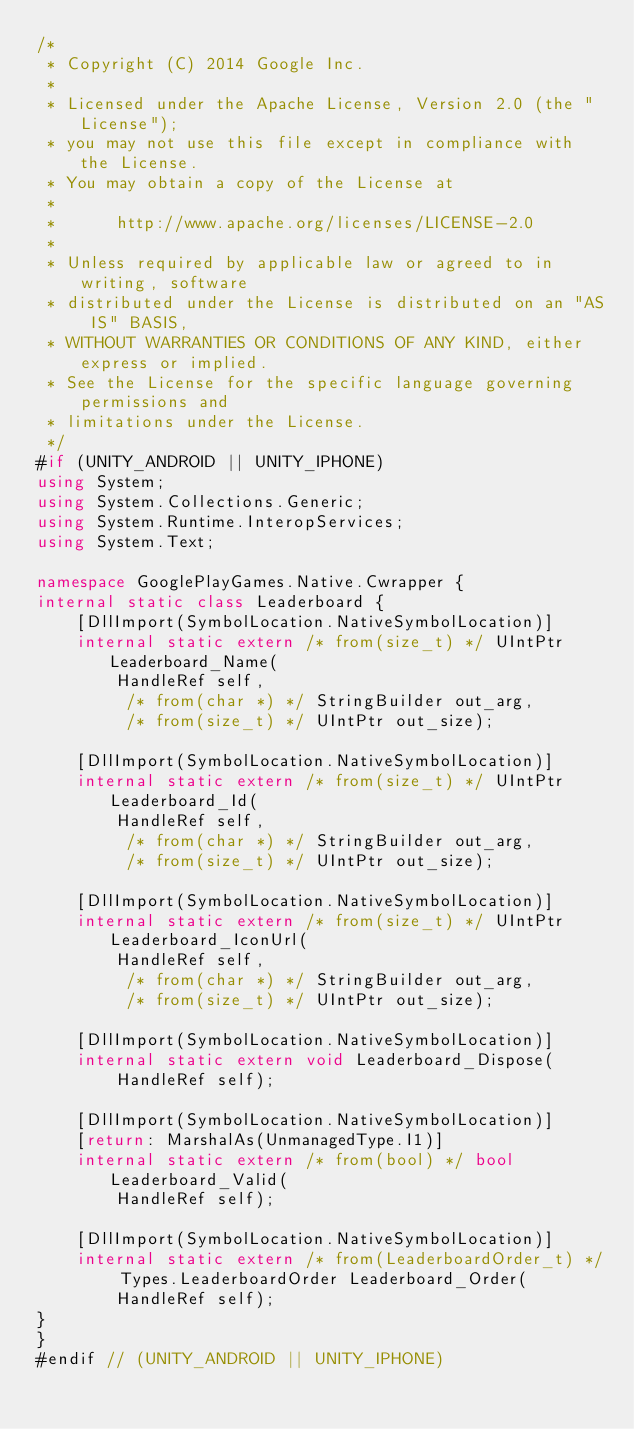<code> <loc_0><loc_0><loc_500><loc_500><_C#_>/*
 * Copyright (C) 2014 Google Inc.
 *
 * Licensed under the Apache License, Version 2.0 (the "License");
 * you may not use this file except in compliance with the License.
 * You may obtain a copy of the License at
 *
 *      http://www.apache.org/licenses/LICENSE-2.0
 *
 * Unless required by applicable law or agreed to in writing, software
 * distributed under the License is distributed on an "AS IS" BASIS,
 * WITHOUT WARRANTIES OR CONDITIONS OF ANY KIND, either express or implied.
 * See the License for the specific language governing permissions and
 * limitations under the License.
 */
#if (UNITY_ANDROID || UNITY_IPHONE)
using System;
using System.Collections.Generic;
using System.Runtime.InteropServices;
using System.Text;

namespace GooglePlayGames.Native.Cwrapper {
internal static class Leaderboard {
    [DllImport(SymbolLocation.NativeSymbolLocation)]
    internal static extern /* from(size_t) */ UIntPtr Leaderboard_Name(
        HandleRef self,
         /* from(char *) */ StringBuilder out_arg,
         /* from(size_t) */ UIntPtr out_size);

    [DllImport(SymbolLocation.NativeSymbolLocation)]
    internal static extern /* from(size_t) */ UIntPtr Leaderboard_Id(
        HandleRef self,
         /* from(char *) */ StringBuilder out_arg,
         /* from(size_t) */ UIntPtr out_size);

    [DllImport(SymbolLocation.NativeSymbolLocation)]
    internal static extern /* from(size_t) */ UIntPtr Leaderboard_IconUrl(
        HandleRef self,
         /* from(char *) */ StringBuilder out_arg,
         /* from(size_t) */ UIntPtr out_size);

    [DllImport(SymbolLocation.NativeSymbolLocation)]
    internal static extern void Leaderboard_Dispose(
        HandleRef self);

    [DllImport(SymbolLocation.NativeSymbolLocation)]
    [return: MarshalAs(UnmanagedType.I1)]
    internal static extern /* from(bool) */ bool Leaderboard_Valid(
        HandleRef self);

    [DllImport(SymbolLocation.NativeSymbolLocation)]
    internal static extern /* from(LeaderboardOrder_t) */ Types.LeaderboardOrder Leaderboard_Order(
        HandleRef self);
}
}
#endif // (UNITY_ANDROID || UNITY_IPHONE)
</code> 